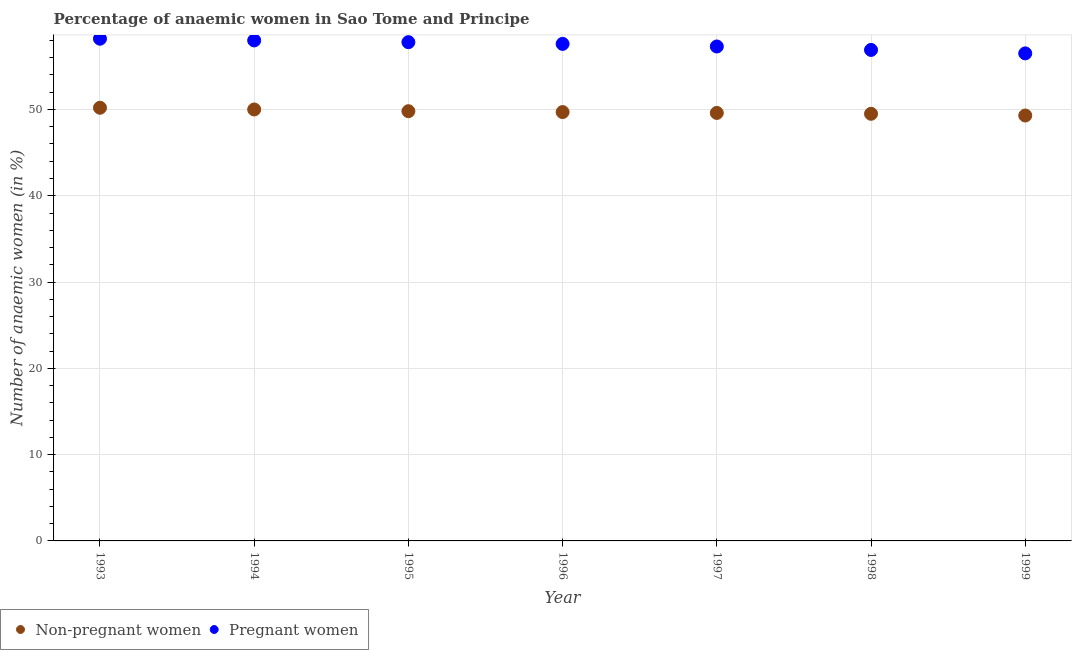How many different coloured dotlines are there?
Offer a very short reply. 2. What is the percentage of non-pregnant anaemic women in 1996?
Provide a succinct answer. 49.7. Across all years, what is the maximum percentage of pregnant anaemic women?
Your answer should be compact. 58.2. Across all years, what is the minimum percentage of pregnant anaemic women?
Keep it short and to the point. 56.5. In which year was the percentage of non-pregnant anaemic women maximum?
Offer a very short reply. 1993. What is the total percentage of pregnant anaemic women in the graph?
Offer a very short reply. 402.3. What is the difference between the percentage of non-pregnant anaemic women in 1995 and that in 1998?
Offer a terse response. 0.3. What is the difference between the percentage of pregnant anaemic women in 1993 and the percentage of non-pregnant anaemic women in 1998?
Ensure brevity in your answer.  8.7. What is the average percentage of pregnant anaemic women per year?
Your answer should be compact. 57.47. In the year 1995, what is the difference between the percentage of non-pregnant anaemic women and percentage of pregnant anaemic women?
Offer a terse response. -8. What is the ratio of the percentage of pregnant anaemic women in 1994 to that in 1999?
Provide a succinct answer. 1.03. What is the difference between the highest and the second highest percentage of non-pregnant anaemic women?
Provide a short and direct response. 0.2. What is the difference between the highest and the lowest percentage of non-pregnant anaemic women?
Your answer should be very brief. 0.9. Is the sum of the percentage of pregnant anaemic women in 1993 and 1997 greater than the maximum percentage of non-pregnant anaemic women across all years?
Make the answer very short. Yes. Does the percentage of non-pregnant anaemic women monotonically increase over the years?
Provide a short and direct response. No. How many dotlines are there?
Ensure brevity in your answer.  2. Are the values on the major ticks of Y-axis written in scientific E-notation?
Give a very brief answer. No. Does the graph contain any zero values?
Give a very brief answer. No. Does the graph contain grids?
Offer a terse response. Yes. Where does the legend appear in the graph?
Provide a short and direct response. Bottom left. How many legend labels are there?
Make the answer very short. 2. What is the title of the graph?
Provide a succinct answer. Percentage of anaemic women in Sao Tome and Principe. Does "Attending school" appear as one of the legend labels in the graph?
Ensure brevity in your answer.  No. What is the label or title of the X-axis?
Your answer should be compact. Year. What is the label or title of the Y-axis?
Offer a very short reply. Number of anaemic women (in %). What is the Number of anaemic women (in %) of Non-pregnant women in 1993?
Your answer should be very brief. 50.2. What is the Number of anaemic women (in %) in Pregnant women in 1993?
Offer a very short reply. 58.2. What is the Number of anaemic women (in %) of Non-pregnant women in 1994?
Make the answer very short. 50. What is the Number of anaemic women (in %) of Non-pregnant women in 1995?
Give a very brief answer. 49.8. What is the Number of anaemic women (in %) of Pregnant women in 1995?
Offer a terse response. 57.8. What is the Number of anaemic women (in %) of Non-pregnant women in 1996?
Provide a succinct answer. 49.7. What is the Number of anaemic women (in %) in Pregnant women in 1996?
Give a very brief answer. 57.6. What is the Number of anaemic women (in %) of Non-pregnant women in 1997?
Your answer should be compact. 49.6. What is the Number of anaemic women (in %) in Pregnant women in 1997?
Provide a short and direct response. 57.3. What is the Number of anaemic women (in %) of Non-pregnant women in 1998?
Offer a terse response. 49.5. What is the Number of anaemic women (in %) in Pregnant women in 1998?
Give a very brief answer. 56.9. What is the Number of anaemic women (in %) in Non-pregnant women in 1999?
Your answer should be very brief. 49.3. What is the Number of anaemic women (in %) in Pregnant women in 1999?
Your answer should be very brief. 56.5. Across all years, what is the maximum Number of anaemic women (in %) in Non-pregnant women?
Give a very brief answer. 50.2. Across all years, what is the maximum Number of anaemic women (in %) of Pregnant women?
Offer a terse response. 58.2. Across all years, what is the minimum Number of anaemic women (in %) of Non-pregnant women?
Provide a succinct answer. 49.3. Across all years, what is the minimum Number of anaemic women (in %) in Pregnant women?
Ensure brevity in your answer.  56.5. What is the total Number of anaemic women (in %) in Non-pregnant women in the graph?
Give a very brief answer. 348.1. What is the total Number of anaemic women (in %) of Pregnant women in the graph?
Provide a succinct answer. 402.3. What is the difference between the Number of anaemic women (in %) in Non-pregnant women in 1993 and that in 1994?
Provide a short and direct response. 0.2. What is the difference between the Number of anaemic women (in %) in Pregnant women in 1993 and that in 1999?
Your response must be concise. 1.7. What is the difference between the Number of anaemic women (in %) of Pregnant women in 1994 and that in 1995?
Offer a terse response. 0.2. What is the difference between the Number of anaemic women (in %) of Non-pregnant women in 1994 and that in 1996?
Make the answer very short. 0.3. What is the difference between the Number of anaemic women (in %) of Pregnant women in 1994 and that in 1996?
Offer a very short reply. 0.4. What is the difference between the Number of anaemic women (in %) in Pregnant women in 1994 and that in 1997?
Offer a terse response. 0.7. What is the difference between the Number of anaemic women (in %) in Non-pregnant women in 1994 and that in 1999?
Your answer should be very brief. 0.7. What is the difference between the Number of anaemic women (in %) in Pregnant women in 1994 and that in 1999?
Offer a terse response. 1.5. What is the difference between the Number of anaemic women (in %) of Non-pregnant women in 1995 and that in 1996?
Your answer should be compact. 0.1. What is the difference between the Number of anaemic women (in %) in Pregnant women in 1995 and that in 1997?
Ensure brevity in your answer.  0.5. What is the difference between the Number of anaemic women (in %) in Non-pregnant women in 1995 and that in 1998?
Make the answer very short. 0.3. What is the difference between the Number of anaemic women (in %) of Non-pregnant women in 1995 and that in 1999?
Your response must be concise. 0.5. What is the difference between the Number of anaemic women (in %) in Pregnant women in 1995 and that in 1999?
Keep it short and to the point. 1.3. What is the difference between the Number of anaemic women (in %) of Pregnant women in 1996 and that in 1997?
Keep it short and to the point. 0.3. What is the difference between the Number of anaemic women (in %) in Non-pregnant women in 1996 and that in 1998?
Your answer should be compact. 0.2. What is the difference between the Number of anaemic women (in %) of Pregnant women in 1997 and that in 1998?
Your answer should be very brief. 0.4. What is the difference between the Number of anaemic women (in %) in Non-pregnant women in 1997 and that in 1999?
Your response must be concise. 0.3. What is the difference between the Number of anaemic women (in %) in Pregnant women in 1997 and that in 1999?
Your answer should be very brief. 0.8. What is the difference between the Number of anaemic women (in %) of Pregnant women in 1998 and that in 1999?
Ensure brevity in your answer.  0.4. What is the difference between the Number of anaemic women (in %) in Non-pregnant women in 1993 and the Number of anaemic women (in %) in Pregnant women in 1994?
Your answer should be very brief. -7.8. What is the difference between the Number of anaemic women (in %) in Non-pregnant women in 1993 and the Number of anaemic women (in %) in Pregnant women in 1997?
Your response must be concise. -7.1. What is the difference between the Number of anaemic women (in %) of Non-pregnant women in 1993 and the Number of anaemic women (in %) of Pregnant women in 1998?
Your response must be concise. -6.7. What is the difference between the Number of anaemic women (in %) of Non-pregnant women in 1994 and the Number of anaemic women (in %) of Pregnant women in 1996?
Keep it short and to the point. -7.6. What is the difference between the Number of anaemic women (in %) of Non-pregnant women in 1995 and the Number of anaemic women (in %) of Pregnant women in 1996?
Keep it short and to the point. -7.8. What is the difference between the Number of anaemic women (in %) in Non-pregnant women in 1995 and the Number of anaemic women (in %) in Pregnant women in 1997?
Provide a succinct answer. -7.5. What is the difference between the Number of anaemic women (in %) in Non-pregnant women in 1995 and the Number of anaemic women (in %) in Pregnant women in 1999?
Ensure brevity in your answer.  -6.7. What is the difference between the Number of anaemic women (in %) of Non-pregnant women in 1996 and the Number of anaemic women (in %) of Pregnant women in 1998?
Provide a short and direct response. -7.2. What is the difference between the Number of anaemic women (in %) in Non-pregnant women in 1997 and the Number of anaemic women (in %) in Pregnant women in 1998?
Offer a very short reply. -7.3. What is the difference between the Number of anaemic women (in %) in Non-pregnant women in 1998 and the Number of anaemic women (in %) in Pregnant women in 1999?
Your answer should be compact. -7. What is the average Number of anaemic women (in %) in Non-pregnant women per year?
Your answer should be very brief. 49.73. What is the average Number of anaemic women (in %) of Pregnant women per year?
Offer a terse response. 57.47. In the year 1993, what is the difference between the Number of anaemic women (in %) in Non-pregnant women and Number of anaemic women (in %) in Pregnant women?
Provide a short and direct response. -8. In the year 1994, what is the difference between the Number of anaemic women (in %) of Non-pregnant women and Number of anaemic women (in %) of Pregnant women?
Your response must be concise. -8. In the year 1995, what is the difference between the Number of anaemic women (in %) in Non-pregnant women and Number of anaemic women (in %) in Pregnant women?
Your answer should be compact. -8. In the year 1997, what is the difference between the Number of anaemic women (in %) in Non-pregnant women and Number of anaemic women (in %) in Pregnant women?
Offer a terse response. -7.7. What is the ratio of the Number of anaemic women (in %) in Non-pregnant women in 1993 to that in 1994?
Your answer should be very brief. 1. What is the ratio of the Number of anaemic women (in %) of Pregnant women in 1993 to that in 1994?
Ensure brevity in your answer.  1. What is the ratio of the Number of anaemic women (in %) in Non-pregnant women in 1993 to that in 1996?
Ensure brevity in your answer.  1.01. What is the ratio of the Number of anaemic women (in %) in Pregnant women in 1993 to that in 1996?
Offer a terse response. 1.01. What is the ratio of the Number of anaemic women (in %) of Non-pregnant women in 1993 to that in 1997?
Keep it short and to the point. 1.01. What is the ratio of the Number of anaemic women (in %) of Pregnant women in 1993 to that in 1997?
Your answer should be compact. 1.02. What is the ratio of the Number of anaemic women (in %) in Non-pregnant women in 1993 to that in 1998?
Your answer should be very brief. 1.01. What is the ratio of the Number of anaemic women (in %) in Pregnant women in 1993 to that in 1998?
Provide a short and direct response. 1.02. What is the ratio of the Number of anaemic women (in %) of Non-pregnant women in 1993 to that in 1999?
Your answer should be compact. 1.02. What is the ratio of the Number of anaemic women (in %) in Pregnant women in 1993 to that in 1999?
Your answer should be compact. 1.03. What is the ratio of the Number of anaemic women (in %) of Non-pregnant women in 1994 to that in 1995?
Your response must be concise. 1. What is the ratio of the Number of anaemic women (in %) in Pregnant women in 1994 to that in 1995?
Your answer should be compact. 1. What is the ratio of the Number of anaemic women (in %) in Non-pregnant women in 1994 to that in 1996?
Keep it short and to the point. 1.01. What is the ratio of the Number of anaemic women (in %) in Pregnant women in 1994 to that in 1996?
Your answer should be very brief. 1.01. What is the ratio of the Number of anaemic women (in %) of Non-pregnant women in 1994 to that in 1997?
Provide a succinct answer. 1.01. What is the ratio of the Number of anaemic women (in %) of Pregnant women in 1994 to that in 1997?
Offer a terse response. 1.01. What is the ratio of the Number of anaemic women (in %) in Pregnant women in 1994 to that in 1998?
Keep it short and to the point. 1.02. What is the ratio of the Number of anaemic women (in %) in Non-pregnant women in 1994 to that in 1999?
Keep it short and to the point. 1.01. What is the ratio of the Number of anaemic women (in %) in Pregnant women in 1994 to that in 1999?
Your response must be concise. 1.03. What is the ratio of the Number of anaemic women (in %) in Pregnant women in 1995 to that in 1997?
Offer a terse response. 1.01. What is the ratio of the Number of anaemic women (in %) of Pregnant women in 1995 to that in 1998?
Give a very brief answer. 1.02. What is the ratio of the Number of anaemic women (in %) in Pregnant women in 1995 to that in 1999?
Offer a very short reply. 1.02. What is the ratio of the Number of anaemic women (in %) of Non-pregnant women in 1996 to that in 1997?
Offer a very short reply. 1. What is the ratio of the Number of anaemic women (in %) of Pregnant women in 1996 to that in 1997?
Keep it short and to the point. 1.01. What is the ratio of the Number of anaemic women (in %) in Non-pregnant women in 1996 to that in 1998?
Offer a very short reply. 1. What is the ratio of the Number of anaemic women (in %) in Pregnant women in 1996 to that in 1998?
Your response must be concise. 1.01. What is the ratio of the Number of anaemic women (in %) of Pregnant women in 1996 to that in 1999?
Ensure brevity in your answer.  1.02. What is the ratio of the Number of anaemic women (in %) of Non-pregnant women in 1997 to that in 1998?
Keep it short and to the point. 1. What is the ratio of the Number of anaemic women (in %) in Non-pregnant women in 1997 to that in 1999?
Give a very brief answer. 1.01. What is the ratio of the Number of anaemic women (in %) in Pregnant women in 1997 to that in 1999?
Give a very brief answer. 1.01. What is the ratio of the Number of anaemic women (in %) in Non-pregnant women in 1998 to that in 1999?
Ensure brevity in your answer.  1. What is the ratio of the Number of anaemic women (in %) in Pregnant women in 1998 to that in 1999?
Offer a very short reply. 1.01. What is the difference between the highest and the second highest Number of anaemic women (in %) in Pregnant women?
Keep it short and to the point. 0.2. What is the difference between the highest and the lowest Number of anaemic women (in %) of Pregnant women?
Give a very brief answer. 1.7. 